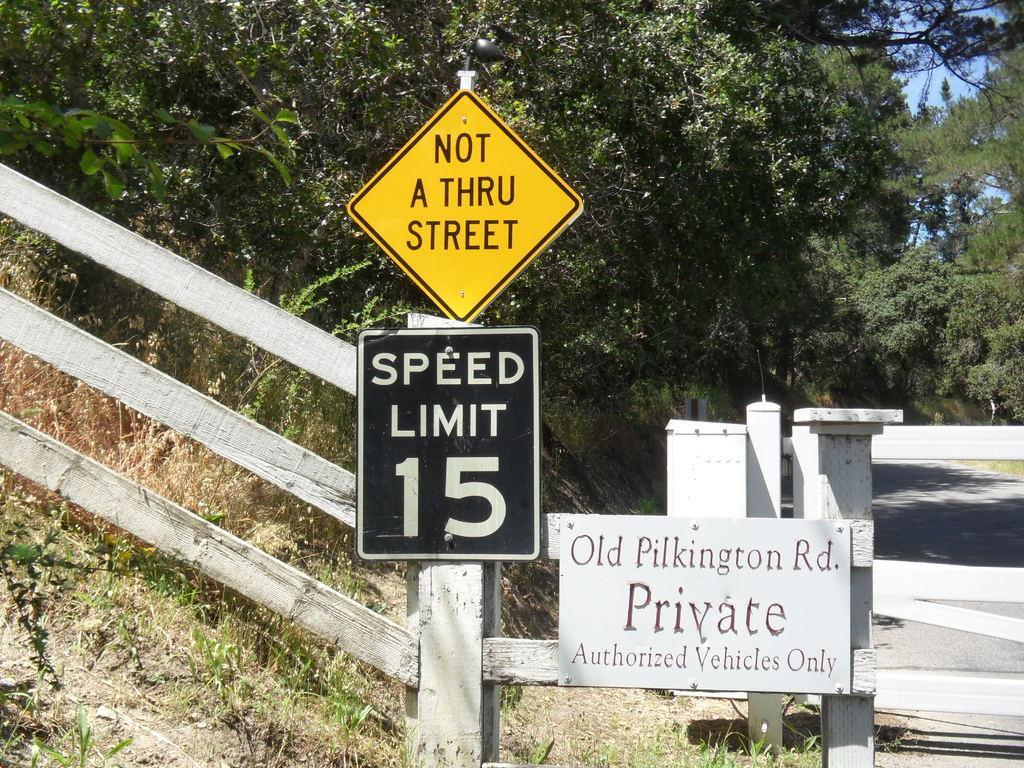How would you summarize this image in a sentence or two? In this image I can see three boards to the railing. These boards are in black, yellow and white color. I can see speed limit, private, street is written on these three boards. In the back I can see many trees, road and the blue sky. 